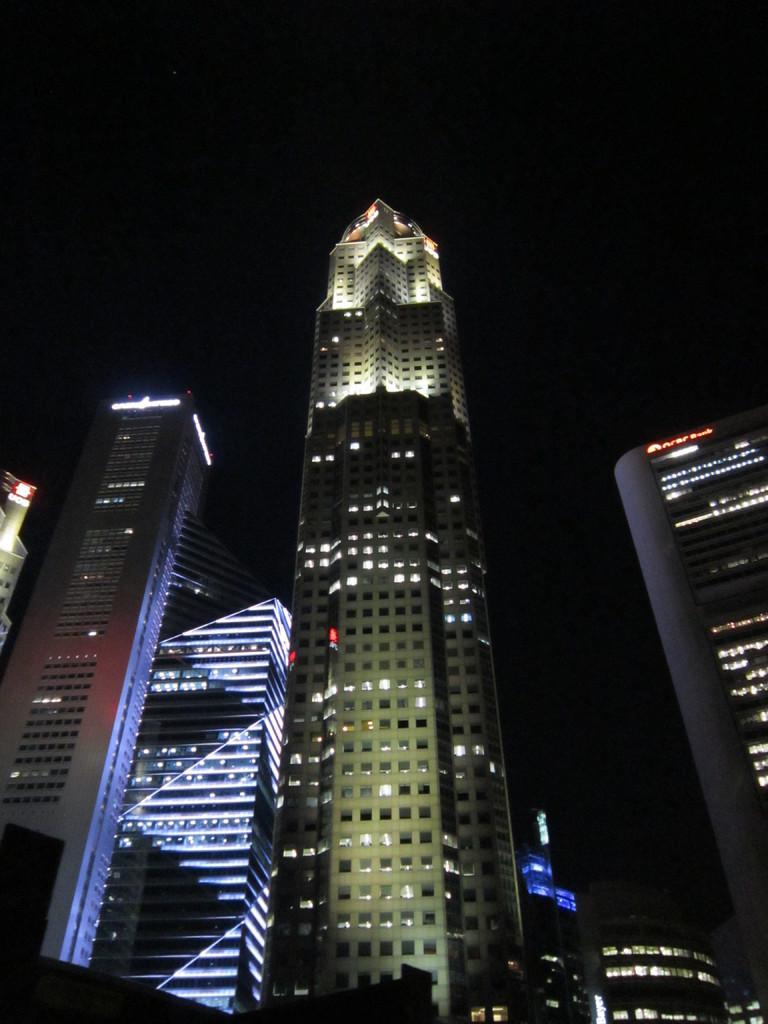Could you give a brief overview of what you see in this image? In this picture we can see the view of buildings from the bottom. The sky is dark. 